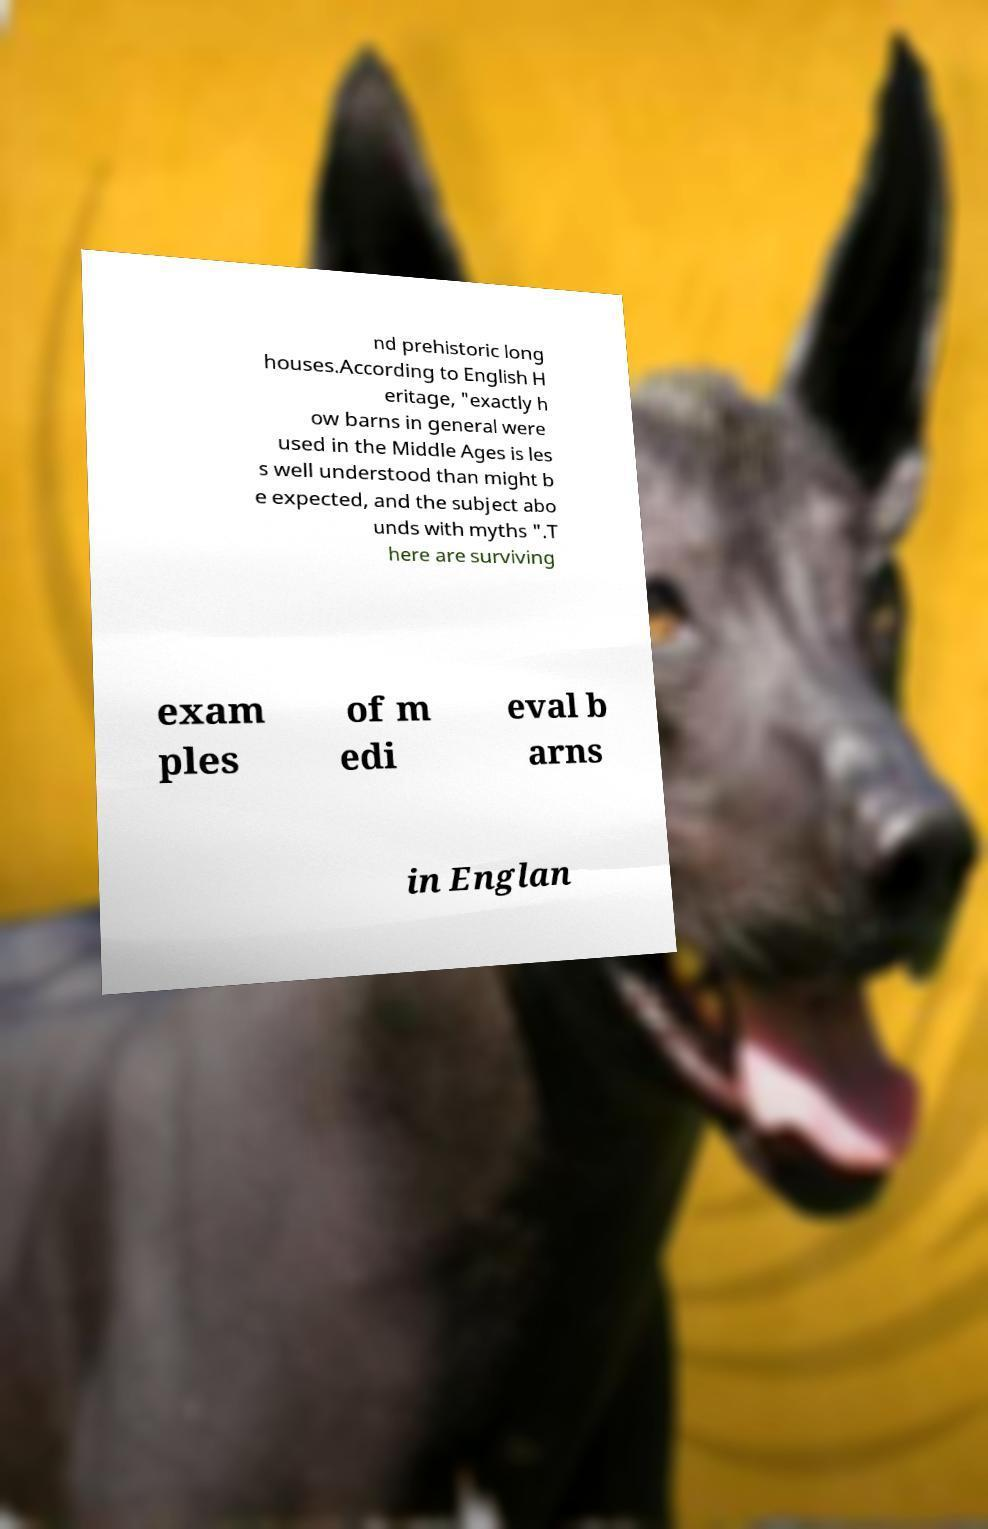Please identify and transcribe the text found in this image. nd prehistoric long houses.According to English H eritage, "exactly h ow barns in general were used in the Middle Ages is les s well understood than might b e expected, and the subject abo unds with myths ".T here are surviving exam ples of m edi eval b arns in Englan 